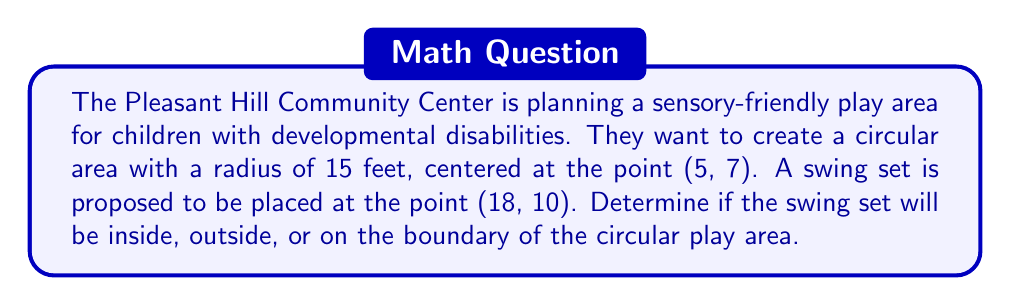Could you help me with this problem? To determine if a point lies inside, outside, or on a circle, we can use the equation of a circle and compare the distance between the point and the center of the circle to the radius of the circle.

Step 1: Identify the key information
- Center of the circle: (5, 7)
- Radius of the circle: 15 feet
- Point to check (swing set location): (18, 10)

Step 2: Calculate the distance between the point and the center of the circle using the distance formula:
$$d = \sqrt{(x_2 - x_1)^2 + (y_2 - y_1)^2}$$

Where $(x_1, y_1)$ is the center of the circle and $(x_2, y_2)$ is the point we're checking.

$$d = \sqrt{(18 - 5)^2 + (10 - 7)^2}$$
$$d = \sqrt{13^2 + 3^2}$$
$$d = \sqrt{169 + 9}$$
$$d = \sqrt{178}$$
$$d \approx 13.34$$

Step 3: Compare the calculated distance to the radius of the circle:
- If $d < 15$, the point is inside the circle.
- If $d = 15$, the point is on the circle.
- If $d > 15$, the point is outside the circle.

Since $13.34 < 15$, the swing set will be inside the circular play area.
Answer: Inside the circle 